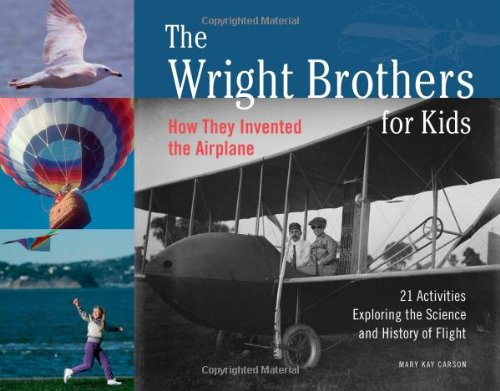Who wrote this book?
Answer the question using a single word or phrase. Mary Kay Carson What is the title of this book? The Wright Brothers for Kids: How They Invented the Airplane, 21 Activities Exploring the Science and History of Flight (For Kids series) What is the genre of this book? Children's Books Is this a kids book? Yes Is this a kids book? No 